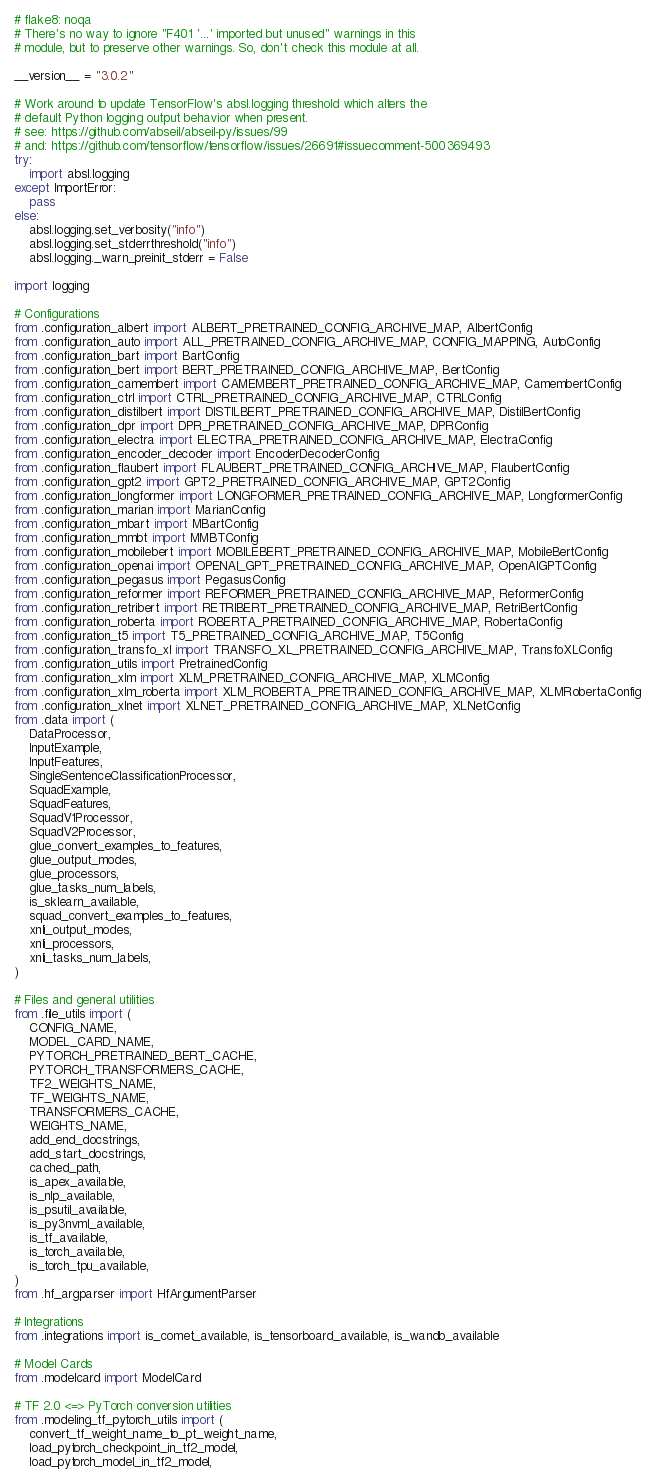<code> <loc_0><loc_0><loc_500><loc_500><_Python_># flake8: noqa
# There's no way to ignore "F401 '...' imported but unused" warnings in this
# module, but to preserve other warnings. So, don't check this module at all.

__version__ = "3.0.2"

# Work around to update TensorFlow's absl.logging threshold which alters the
# default Python logging output behavior when present.
# see: https://github.com/abseil/abseil-py/issues/99
# and: https://github.com/tensorflow/tensorflow/issues/26691#issuecomment-500369493
try:
    import absl.logging
except ImportError:
    pass
else:
    absl.logging.set_verbosity("info")
    absl.logging.set_stderrthreshold("info")
    absl.logging._warn_preinit_stderr = False

import logging

# Configurations
from .configuration_albert import ALBERT_PRETRAINED_CONFIG_ARCHIVE_MAP, AlbertConfig
from .configuration_auto import ALL_PRETRAINED_CONFIG_ARCHIVE_MAP, CONFIG_MAPPING, AutoConfig
from .configuration_bart import BartConfig
from .configuration_bert import BERT_PRETRAINED_CONFIG_ARCHIVE_MAP, BertConfig
from .configuration_camembert import CAMEMBERT_PRETRAINED_CONFIG_ARCHIVE_MAP, CamembertConfig
from .configuration_ctrl import CTRL_PRETRAINED_CONFIG_ARCHIVE_MAP, CTRLConfig
from .configuration_distilbert import DISTILBERT_PRETRAINED_CONFIG_ARCHIVE_MAP, DistilBertConfig
from .configuration_dpr import DPR_PRETRAINED_CONFIG_ARCHIVE_MAP, DPRConfig
from .configuration_electra import ELECTRA_PRETRAINED_CONFIG_ARCHIVE_MAP, ElectraConfig
from .configuration_encoder_decoder import EncoderDecoderConfig
from .configuration_flaubert import FLAUBERT_PRETRAINED_CONFIG_ARCHIVE_MAP, FlaubertConfig
from .configuration_gpt2 import GPT2_PRETRAINED_CONFIG_ARCHIVE_MAP, GPT2Config
from .configuration_longformer import LONGFORMER_PRETRAINED_CONFIG_ARCHIVE_MAP, LongformerConfig
from .configuration_marian import MarianConfig
from .configuration_mbart import MBartConfig
from .configuration_mmbt import MMBTConfig
from .configuration_mobilebert import MOBILEBERT_PRETRAINED_CONFIG_ARCHIVE_MAP, MobileBertConfig
from .configuration_openai import OPENAI_GPT_PRETRAINED_CONFIG_ARCHIVE_MAP, OpenAIGPTConfig
from .configuration_pegasus import PegasusConfig
from .configuration_reformer import REFORMER_PRETRAINED_CONFIG_ARCHIVE_MAP, ReformerConfig
from .configuration_retribert import RETRIBERT_PRETRAINED_CONFIG_ARCHIVE_MAP, RetriBertConfig
from .configuration_roberta import ROBERTA_PRETRAINED_CONFIG_ARCHIVE_MAP, RobertaConfig
from .configuration_t5 import T5_PRETRAINED_CONFIG_ARCHIVE_MAP, T5Config
from .configuration_transfo_xl import TRANSFO_XL_PRETRAINED_CONFIG_ARCHIVE_MAP, TransfoXLConfig
from .configuration_utils import PretrainedConfig
from .configuration_xlm import XLM_PRETRAINED_CONFIG_ARCHIVE_MAP, XLMConfig
from .configuration_xlm_roberta import XLM_ROBERTA_PRETRAINED_CONFIG_ARCHIVE_MAP, XLMRobertaConfig
from .configuration_xlnet import XLNET_PRETRAINED_CONFIG_ARCHIVE_MAP, XLNetConfig
from .data import (
    DataProcessor,
    InputExample,
    InputFeatures,
    SingleSentenceClassificationProcessor,
    SquadExample,
    SquadFeatures,
    SquadV1Processor,
    SquadV2Processor,
    glue_convert_examples_to_features,
    glue_output_modes,
    glue_processors,
    glue_tasks_num_labels,
    is_sklearn_available,
    squad_convert_examples_to_features,
    xnli_output_modes,
    xnli_processors,
    xnli_tasks_num_labels,
)

# Files and general utilities
from .file_utils import (
    CONFIG_NAME,
    MODEL_CARD_NAME,
    PYTORCH_PRETRAINED_BERT_CACHE,
    PYTORCH_TRANSFORMERS_CACHE,
    TF2_WEIGHTS_NAME,
    TF_WEIGHTS_NAME,
    TRANSFORMERS_CACHE,
    WEIGHTS_NAME,
    add_end_docstrings,
    add_start_docstrings,
    cached_path,
    is_apex_available,
    is_nlp_available,
    is_psutil_available,
    is_py3nvml_available,
    is_tf_available,
    is_torch_available,
    is_torch_tpu_available,
)
from .hf_argparser import HfArgumentParser

# Integrations
from .integrations import is_comet_available, is_tensorboard_available, is_wandb_available

# Model Cards
from .modelcard import ModelCard

# TF 2.0 <=> PyTorch conversion utilities
from .modeling_tf_pytorch_utils import (
    convert_tf_weight_name_to_pt_weight_name,
    load_pytorch_checkpoint_in_tf2_model,
    load_pytorch_model_in_tf2_model,</code> 